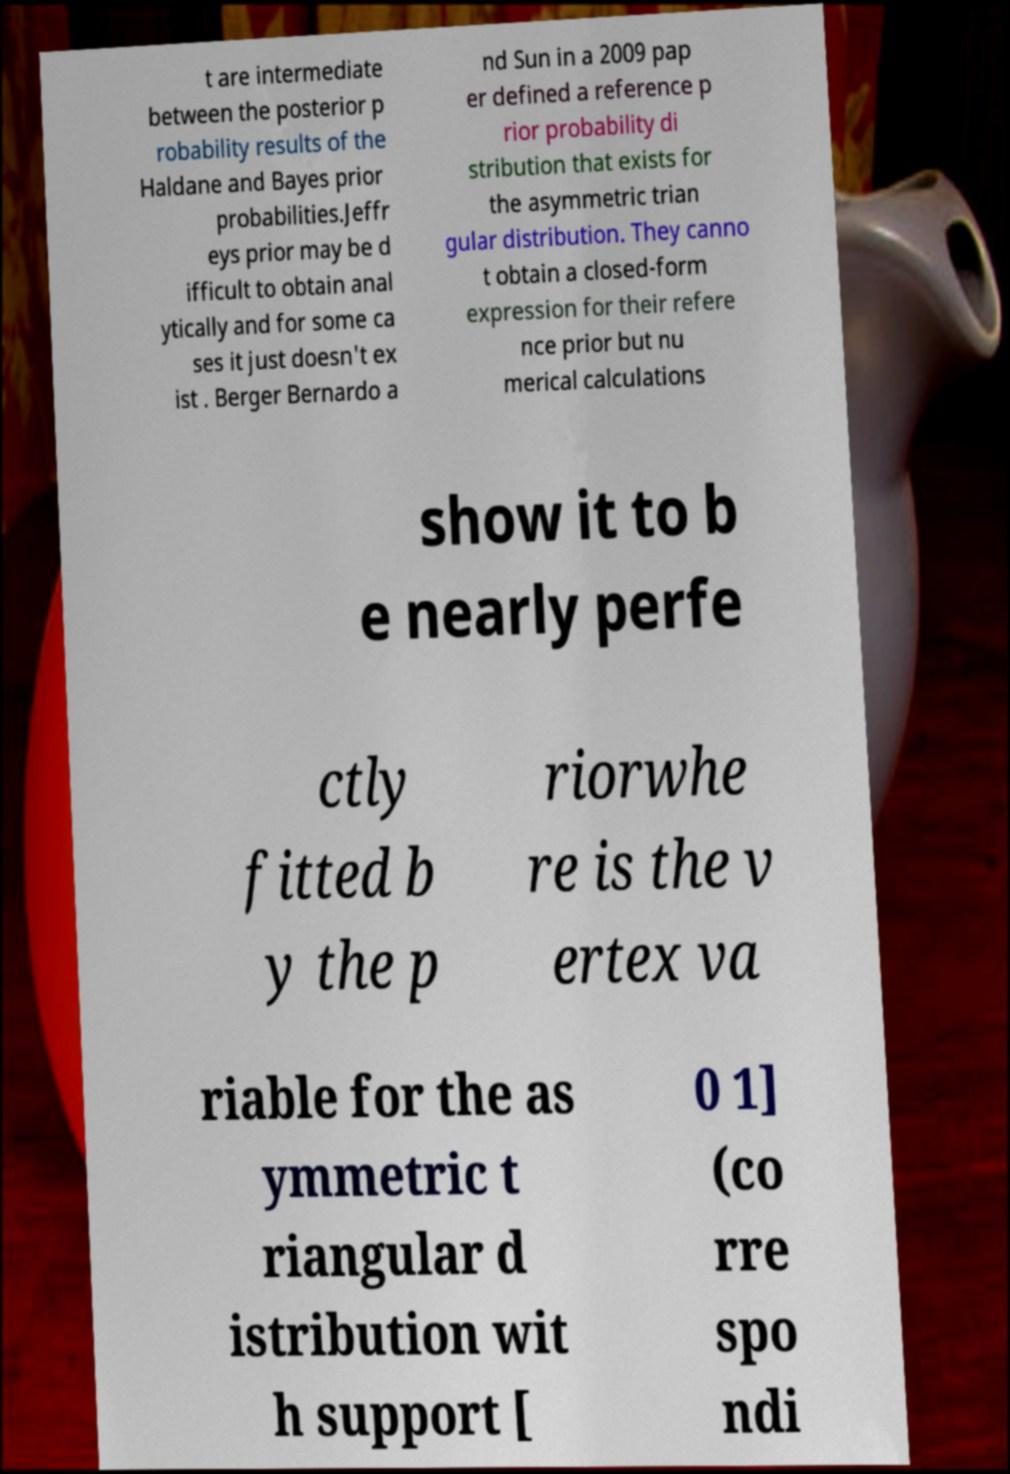Please read and relay the text visible in this image. What does it say? t are intermediate between the posterior p robability results of the Haldane and Bayes prior probabilities.Jeffr eys prior may be d ifficult to obtain anal ytically and for some ca ses it just doesn't ex ist . Berger Bernardo a nd Sun in a 2009 pap er defined a reference p rior probability di stribution that exists for the asymmetric trian gular distribution. They canno t obtain a closed-form expression for their refere nce prior but nu merical calculations show it to b e nearly perfe ctly fitted b y the p riorwhe re is the v ertex va riable for the as ymmetric t riangular d istribution wit h support [ 0 1] (co rre spo ndi 